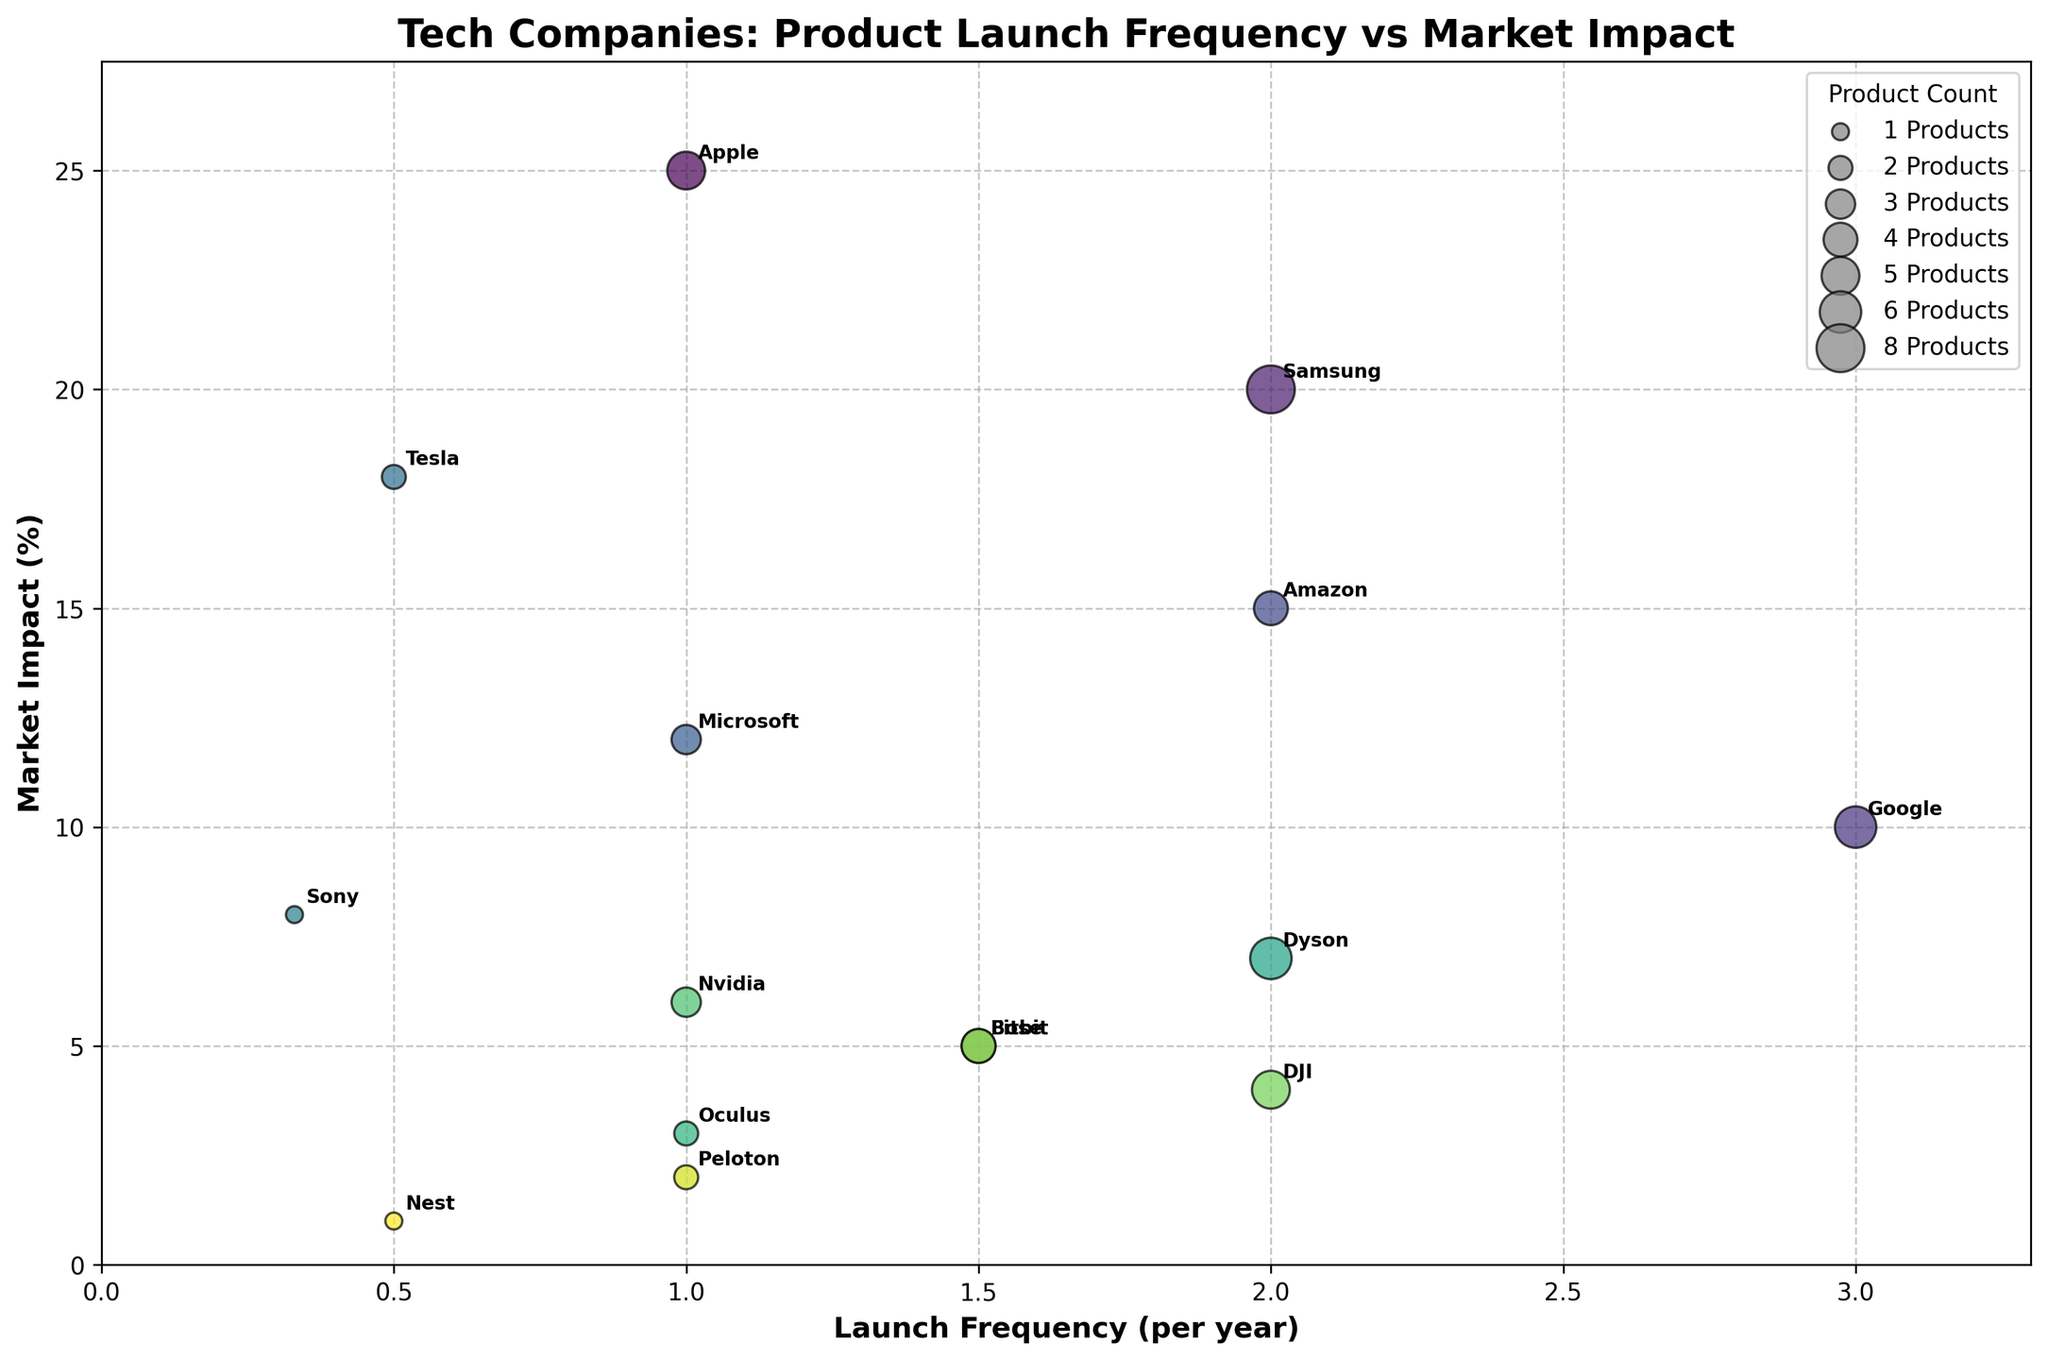What is the company with the highest Market Impact? To find the company with the highest Market Impact, look at the data points and identify the one with the largest value on the y-axis (Market Impact %). From the figure, Apple has the highest Market Impact at 25%.
Answer: Apple How many products does the company with the lowest Launch Frequency offer? The company with the lowest Launch Frequency has a frequency value of 0.33 per year, which is Sony. Sony offers 1 product, according to the bubble size legend and data points.
Answer: 1 Which product type has the highest Launch Frequency and which company offers it? To find the product type with the highest Launch Frequency, look for the largest x-axis value. Google has the highest Launch Frequency for Smart Home Devices, at 3 per year.
Answer: Smart Home Devices, Google What is the combined Market Impact of Tesla and Peloton? To find the combined Market Impact, sum the Market Impact percentages of Tesla and Peloton. Tesla has an 18% Market Impact, and Peloton has 2%. The combined Market Impact is 18% + 2% = 20%.
Answer: 20% Which company has a higher Market Impact: Amazon or Oculus? Compare the y-axis values for Amazon and Oculus. Amazon has a Market Impact of 15%, while Oculus has a Market Impact of 3%. Therefore, Amazon has a higher Market Impact than Oculus.
Answer: Amazon How does the Launch Frequency of Dyson compare with that of Samsung? To compare the Launch Frequencies, look at their values on the x-axis. Both Dyson and Samsung have a Launch Frequency of 2 per year, meaning they have equal Launch Frequencies.
Answer: Equal What is the title of the figure? The title is usually displayed at the top of the figure. For this figure, the title is "Tech Companies: Product Launch Frequency vs Market Impact."
Answer: Tech Companies: Product Launch Frequency vs Market Impact How does the product count for Nvidia compare to that of Fitbit? Compare the bubble sizes for Nvidia and Fitbit, or refer to the provided data. Nvidia has 3 products, whereas Fitbit has 4 products. Therefore, Fitbit has a higher product count.
Answer: Fitbit Which company has a Launch Frequency of 1.5 per year and what is its Market Impact? Identify the company by looking at the data points with a Launch Frequency of 1.5 per year. Both Fitbit and Bose have this Launch Frequency. Fitbit’s Market Impact is 5%, and Bose's is also 5%.
Answer: Fitbit, Bose (5%) each Which company is represented by the largest bubble and what does it indicate? The largest bubble represents the company with the highest product count. In the figure, Samsung is the company with the largest bubble, indicating it offers the most products (8).
Answer: Samsung 